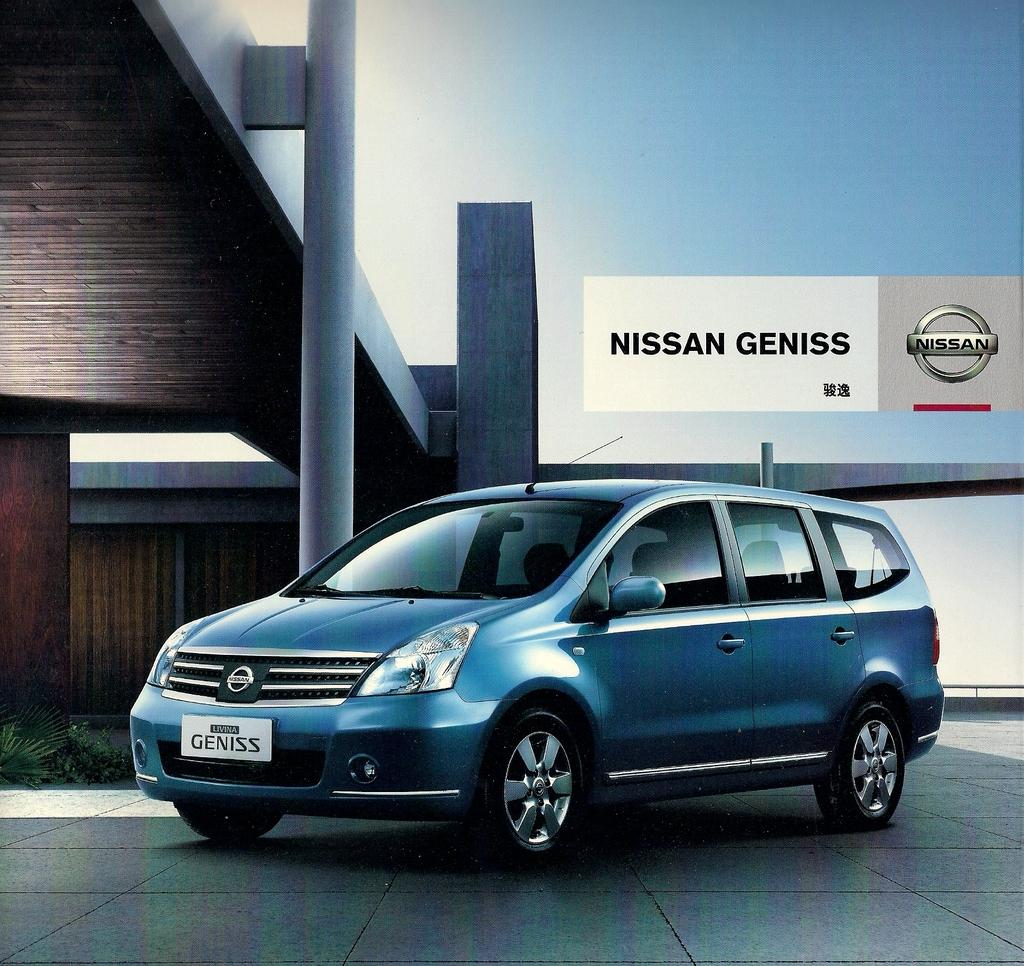<image>
Relay a brief, clear account of the picture shown. A blue 4 door minivan called Genesis by Nissan. 